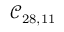<formula> <loc_0><loc_0><loc_500><loc_500>\mathcal { C } _ { 2 8 , 1 1 }</formula> 